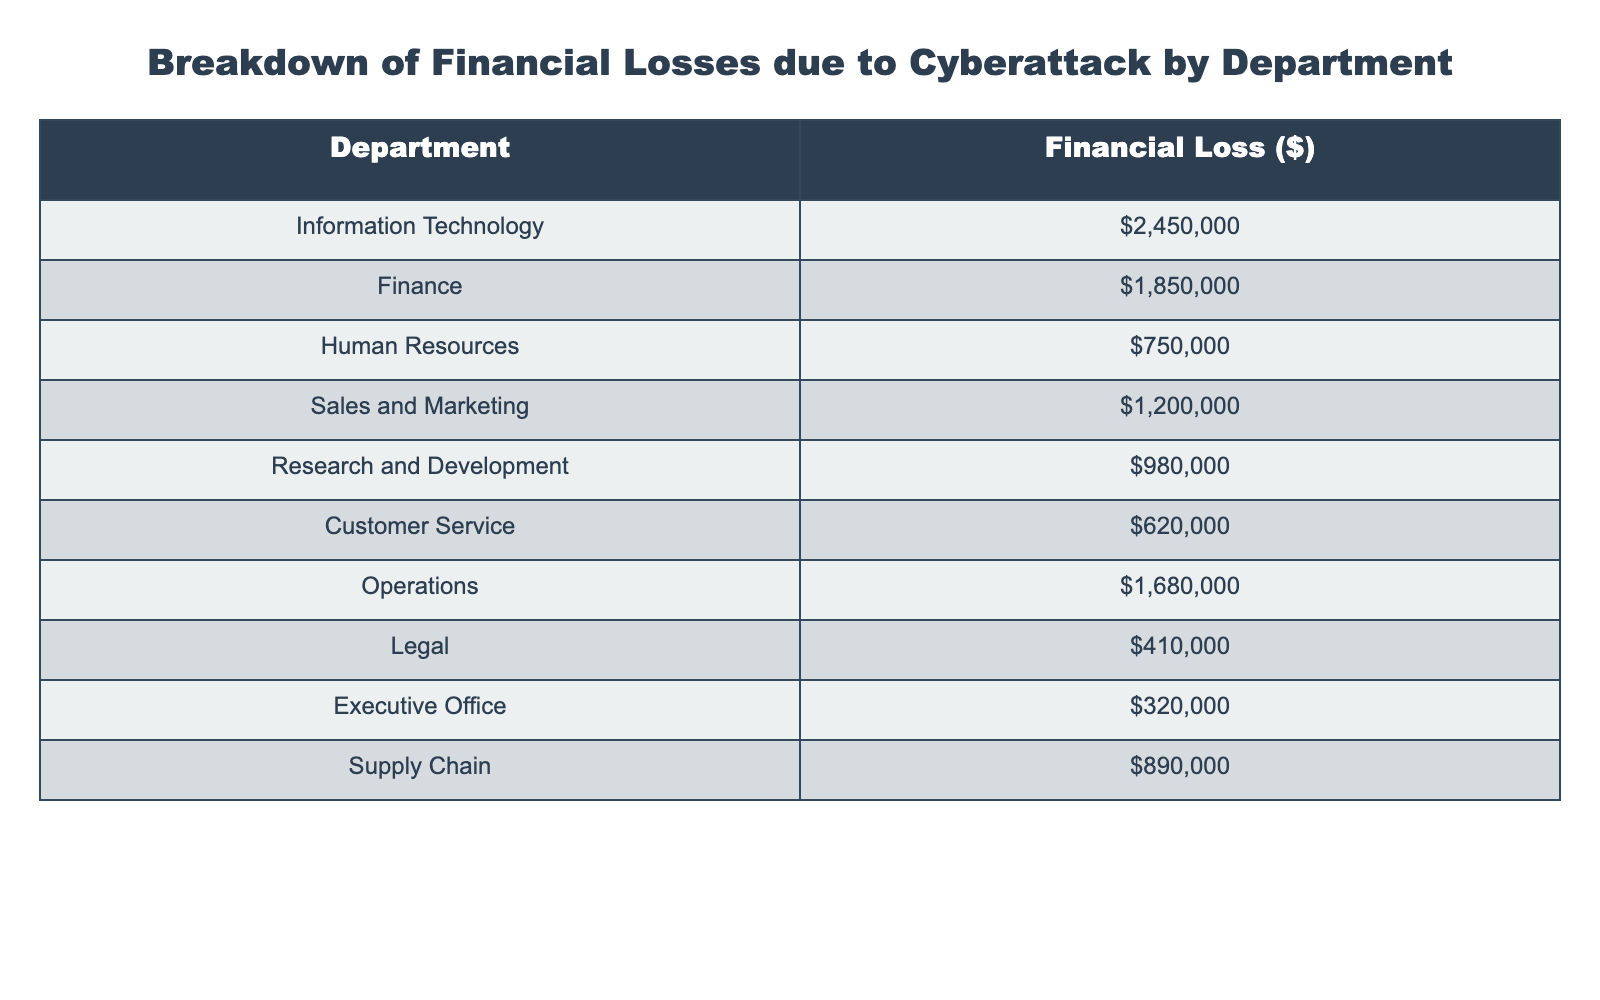What is the financial loss incurred by the Information Technology department? According to the table, the Information Technology department has a reported financial loss of $2,450,000.
Answer: $2,450,000 Which department suffered the highest financial loss? The table indicates that the Information Technology department experienced the highest financial loss, amounting to $2,450,000.
Answer: Information Technology What is the total financial loss across all departments due to the cyberattack? By adding the financial losses from each department: 2,450,000 + 1,850,000 + 750,000 + 1,200,000 + 980,000 + 620,000 + 1,680,000 + 410,000 + 320,000 + 890,000, we get a total of $10,860,000.
Answer: $10,860,000 What is the average financial loss per department? There are 10 departments listed, and the total financial loss is $10,860,000. To find the average, we divide the total by the number of departments: $10,860,000 / 10 = $1,086,000.
Answer: $1,086,000 Is the financial loss in the Human Resources department greater than $1 million? The table shows that the financial loss in the Human Resources department is $750,000, which is less than $1 million.
Answer: No How much more did the Operations department lose compared to the Customer Service department? The Operations department lost $1,680,000, and the Customer Service department lost $620,000. The difference is calculated by subtracting: $1,680,000 - $620,000 = $1,060,000.
Answer: $1,060,000 What percentage of the total financial loss is attributed to the Finance department? The Finance department's loss is $1,850,000, and the total loss is $10,860,000. To find the percentage, we use the formula: ($1,850,000 / $10,860,000) * 100, resulting in approximately 17%.
Answer: 17% Which two departments combined have the lowest financial loss? The departments with the lowest financial losses are Human Resources ($750,000) and Customer Service ($620,000). Adding these gives $750,000 + $620,000 = $1,370,000, the minimum combined loss.
Answer: $1,370,000 If the Legal department's loss is excluded, what is the new total financial loss? The total loss excluding the Legal department ($410,000) would be calculated as $10,860,000 - $410,000, resulting in a new total of $10,450,000.
Answer: $10,450,000 How much did Research and Development lose compared to the Sales and Marketing department? The Research and Development department lost $980,000, while Sales and Marketing lost $1,200,000. The difference is $1,200,000 - $980,000 = $220,000.
Answer: $220,000 